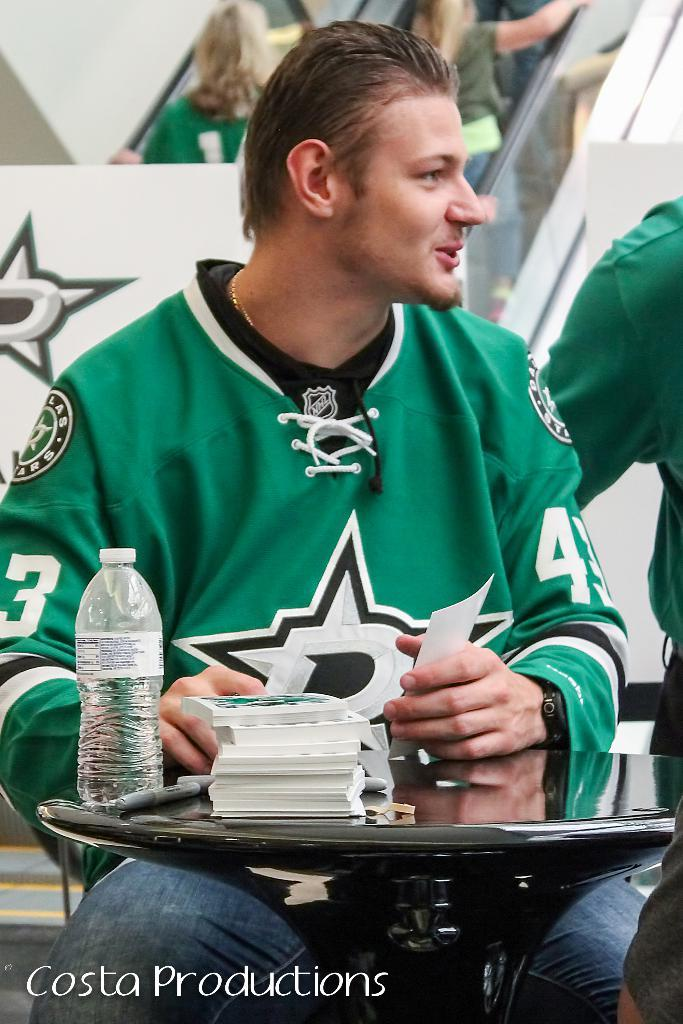Who is present in the image? There is a man in the image. What is the man doing in the image? The man is seated in the image. What is the man's facial expression in the image? The man is smiling in the image. What can be seen on the table in the image? There is a water bottle and papers on the table in the image. What type of oatmeal is the man eating in the image? There is no oatmeal present in the image; the man is seated and smiling, but no food is visible. What color is the skirt the man is wearing in the image? The man is not wearing a skirt in the image; he is wearing regular clothing appropriate for a seated position. 